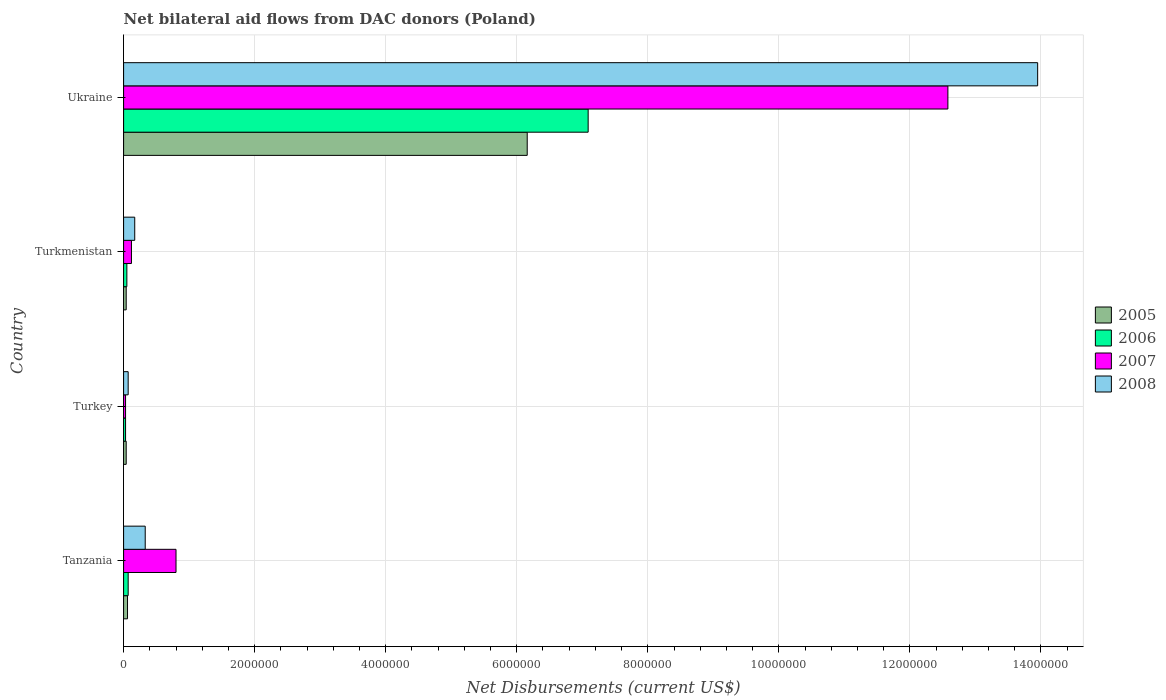How many different coloured bars are there?
Make the answer very short. 4. How many groups of bars are there?
Give a very brief answer. 4. Are the number of bars per tick equal to the number of legend labels?
Give a very brief answer. Yes. How many bars are there on the 2nd tick from the bottom?
Ensure brevity in your answer.  4. Across all countries, what is the maximum net bilateral aid flows in 2006?
Keep it short and to the point. 7.09e+06. In which country was the net bilateral aid flows in 2008 maximum?
Your answer should be very brief. Ukraine. In which country was the net bilateral aid flows in 2008 minimum?
Provide a succinct answer. Turkey. What is the total net bilateral aid flows in 2008 in the graph?
Give a very brief answer. 1.45e+07. What is the difference between the net bilateral aid flows in 2005 in Turkmenistan and that in Ukraine?
Provide a short and direct response. -6.12e+06. What is the difference between the net bilateral aid flows in 2006 in Ukraine and the net bilateral aid flows in 2005 in Turkmenistan?
Give a very brief answer. 7.05e+06. What is the average net bilateral aid flows in 2006 per country?
Your answer should be very brief. 1.81e+06. What is the difference between the net bilateral aid flows in 2006 and net bilateral aid flows in 2005 in Turkmenistan?
Your answer should be very brief. 10000. What is the ratio of the net bilateral aid flows in 2007 in Tanzania to that in Turkmenistan?
Provide a short and direct response. 6.67. Is the net bilateral aid flows in 2006 in Tanzania less than that in Ukraine?
Make the answer very short. Yes. What is the difference between the highest and the second highest net bilateral aid flows in 2007?
Provide a short and direct response. 1.18e+07. What is the difference between the highest and the lowest net bilateral aid flows in 2008?
Give a very brief answer. 1.39e+07. In how many countries, is the net bilateral aid flows in 2006 greater than the average net bilateral aid flows in 2006 taken over all countries?
Provide a succinct answer. 1. Is the sum of the net bilateral aid flows in 2006 in Tanzania and Turkmenistan greater than the maximum net bilateral aid flows in 2008 across all countries?
Make the answer very short. No. Is it the case that in every country, the sum of the net bilateral aid flows in 2008 and net bilateral aid flows in 2005 is greater than the sum of net bilateral aid flows in 2006 and net bilateral aid flows in 2007?
Keep it short and to the point. No. What does the 3rd bar from the top in Turkey represents?
Offer a terse response. 2006. What does the 1st bar from the bottom in Turkmenistan represents?
Offer a very short reply. 2005. How many bars are there?
Make the answer very short. 16. Does the graph contain grids?
Your answer should be compact. Yes. What is the title of the graph?
Ensure brevity in your answer.  Net bilateral aid flows from DAC donors (Poland). Does "1982" appear as one of the legend labels in the graph?
Make the answer very short. No. What is the label or title of the X-axis?
Provide a succinct answer. Net Disbursements (current US$). What is the label or title of the Y-axis?
Your answer should be compact. Country. What is the Net Disbursements (current US$) of 2005 in Tanzania?
Ensure brevity in your answer.  6.00e+04. What is the Net Disbursements (current US$) in 2006 in Tanzania?
Offer a very short reply. 7.00e+04. What is the Net Disbursements (current US$) in 2006 in Turkey?
Your answer should be very brief. 3.00e+04. What is the Net Disbursements (current US$) of 2007 in Turkmenistan?
Your answer should be very brief. 1.20e+05. What is the Net Disbursements (current US$) in 2005 in Ukraine?
Make the answer very short. 6.16e+06. What is the Net Disbursements (current US$) of 2006 in Ukraine?
Give a very brief answer. 7.09e+06. What is the Net Disbursements (current US$) of 2007 in Ukraine?
Your response must be concise. 1.26e+07. What is the Net Disbursements (current US$) of 2008 in Ukraine?
Offer a very short reply. 1.40e+07. Across all countries, what is the maximum Net Disbursements (current US$) of 2005?
Offer a very short reply. 6.16e+06. Across all countries, what is the maximum Net Disbursements (current US$) in 2006?
Give a very brief answer. 7.09e+06. Across all countries, what is the maximum Net Disbursements (current US$) in 2007?
Make the answer very short. 1.26e+07. Across all countries, what is the maximum Net Disbursements (current US$) of 2008?
Your answer should be very brief. 1.40e+07. Across all countries, what is the minimum Net Disbursements (current US$) in 2006?
Give a very brief answer. 3.00e+04. Across all countries, what is the minimum Net Disbursements (current US$) of 2007?
Keep it short and to the point. 3.00e+04. Across all countries, what is the minimum Net Disbursements (current US$) in 2008?
Provide a succinct answer. 7.00e+04. What is the total Net Disbursements (current US$) in 2005 in the graph?
Ensure brevity in your answer.  6.30e+06. What is the total Net Disbursements (current US$) of 2006 in the graph?
Your answer should be compact. 7.24e+06. What is the total Net Disbursements (current US$) of 2007 in the graph?
Offer a terse response. 1.35e+07. What is the total Net Disbursements (current US$) of 2008 in the graph?
Provide a succinct answer. 1.45e+07. What is the difference between the Net Disbursements (current US$) of 2005 in Tanzania and that in Turkey?
Give a very brief answer. 2.00e+04. What is the difference between the Net Disbursements (current US$) of 2006 in Tanzania and that in Turkey?
Your answer should be very brief. 4.00e+04. What is the difference between the Net Disbursements (current US$) in 2007 in Tanzania and that in Turkey?
Ensure brevity in your answer.  7.70e+05. What is the difference between the Net Disbursements (current US$) in 2008 in Tanzania and that in Turkey?
Make the answer very short. 2.60e+05. What is the difference between the Net Disbursements (current US$) of 2006 in Tanzania and that in Turkmenistan?
Keep it short and to the point. 2.00e+04. What is the difference between the Net Disbursements (current US$) in 2007 in Tanzania and that in Turkmenistan?
Your answer should be very brief. 6.80e+05. What is the difference between the Net Disbursements (current US$) of 2005 in Tanzania and that in Ukraine?
Provide a succinct answer. -6.10e+06. What is the difference between the Net Disbursements (current US$) in 2006 in Tanzania and that in Ukraine?
Your response must be concise. -7.02e+06. What is the difference between the Net Disbursements (current US$) in 2007 in Tanzania and that in Ukraine?
Your answer should be compact. -1.18e+07. What is the difference between the Net Disbursements (current US$) of 2008 in Tanzania and that in Ukraine?
Your answer should be compact. -1.36e+07. What is the difference between the Net Disbursements (current US$) of 2005 in Turkey and that in Turkmenistan?
Provide a short and direct response. 0. What is the difference between the Net Disbursements (current US$) of 2008 in Turkey and that in Turkmenistan?
Your answer should be very brief. -1.00e+05. What is the difference between the Net Disbursements (current US$) in 2005 in Turkey and that in Ukraine?
Provide a short and direct response. -6.12e+06. What is the difference between the Net Disbursements (current US$) of 2006 in Turkey and that in Ukraine?
Offer a terse response. -7.06e+06. What is the difference between the Net Disbursements (current US$) of 2007 in Turkey and that in Ukraine?
Make the answer very short. -1.26e+07. What is the difference between the Net Disbursements (current US$) in 2008 in Turkey and that in Ukraine?
Make the answer very short. -1.39e+07. What is the difference between the Net Disbursements (current US$) in 2005 in Turkmenistan and that in Ukraine?
Provide a succinct answer. -6.12e+06. What is the difference between the Net Disbursements (current US$) of 2006 in Turkmenistan and that in Ukraine?
Your response must be concise. -7.04e+06. What is the difference between the Net Disbursements (current US$) of 2007 in Turkmenistan and that in Ukraine?
Give a very brief answer. -1.25e+07. What is the difference between the Net Disbursements (current US$) of 2008 in Turkmenistan and that in Ukraine?
Offer a very short reply. -1.38e+07. What is the difference between the Net Disbursements (current US$) of 2006 in Tanzania and the Net Disbursements (current US$) of 2008 in Turkey?
Provide a short and direct response. 0. What is the difference between the Net Disbursements (current US$) of 2007 in Tanzania and the Net Disbursements (current US$) of 2008 in Turkey?
Ensure brevity in your answer.  7.30e+05. What is the difference between the Net Disbursements (current US$) in 2005 in Tanzania and the Net Disbursements (current US$) in 2006 in Turkmenistan?
Your answer should be compact. 10000. What is the difference between the Net Disbursements (current US$) in 2005 in Tanzania and the Net Disbursements (current US$) in 2008 in Turkmenistan?
Provide a short and direct response. -1.10e+05. What is the difference between the Net Disbursements (current US$) in 2006 in Tanzania and the Net Disbursements (current US$) in 2007 in Turkmenistan?
Give a very brief answer. -5.00e+04. What is the difference between the Net Disbursements (current US$) in 2006 in Tanzania and the Net Disbursements (current US$) in 2008 in Turkmenistan?
Offer a terse response. -1.00e+05. What is the difference between the Net Disbursements (current US$) in 2007 in Tanzania and the Net Disbursements (current US$) in 2008 in Turkmenistan?
Make the answer very short. 6.30e+05. What is the difference between the Net Disbursements (current US$) of 2005 in Tanzania and the Net Disbursements (current US$) of 2006 in Ukraine?
Keep it short and to the point. -7.03e+06. What is the difference between the Net Disbursements (current US$) of 2005 in Tanzania and the Net Disbursements (current US$) of 2007 in Ukraine?
Your answer should be very brief. -1.25e+07. What is the difference between the Net Disbursements (current US$) in 2005 in Tanzania and the Net Disbursements (current US$) in 2008 in Ukraine?
Provide a succinct answer. -1.39e+07. What is the difference between the Net Disbursements (current US$) in 2006 in Tanzania and the Net Disbursements (current US$) in 2007 in Ukraine?
Your answer should be compact. -1.25e+07. What is the difference between the Net Disbursements (current US$) in 2006 in Tanzania and the Net Disbursements (current US$) in 2008 in Ukraine?
Offer a very short reply. -1.39e+07. What is the difference between the Net Disbursements (current US$) in 2007 in Tanzania and the Net Disbursements (current US$) in 2008 in Ukraine?
Make the answer very short. -1.32e+07. What is the difference between the Net Disbursements (current US$) of 2005 in Turkey and the Net Disbursements (current US$) of 2006 in Turkmenistan?
Make the answer very short. -10000. What is the difference between the Net Disbursements (current US$) of 2005 in Turkey and the Net Disbursements (current US$) of 2008 in Turkmenistan?
Your answer should be very brief. -1.30e+05. What is the difference between the Net Disbursements (current US$) in 2006 in Turkey and the Net Disbursements (current US$) in 2007 in Turkmenistan?
Your answer should be very brief. -9.00e+04. What is the difference between the Net Disbursements (current US$) in 2007 in Turkey and the Net Disbursements (current US$) in 2008 in Turkmenistan?
Your answer should be compact. -1.40e+05. What is the difference between the Net Disbursements (current US$) in 2005 in Turkey and the Net Disbursements (current US$) in 2006 in Ukraine?
Offer a very short reply. -7.05e+06. What is the difference between the Net Disbursements (current US$) of 2005 in Turkey and the Net Disbursements (current US$) of 2007 in Ukraine?
Provide a succinct answer. -1.25e+07. What is the difference between the Net Disbursements (current US$) in 2005 in Turkey and the Net Disbursements (current US$) in 2008 in Ukraine?
Offer a very short reply. -1.39e+07. What is the difference between the Net Disbursements (current US$) in 2006 in Turkey and the Net Disbursements (current US$) in 2007 in Ukraine?
Give a very brief answer. -1.26e+07. What is the difference between the Net Disbursements (current US$) in 2006 in Turkey and the Net Disbursements (current US$) in 2008 in Ukraine?
Give a very brief answer. -1.39e+07. What is the difference between the Net Disbursements (current US$) in 2007 in Turkey and the Net Disbursements (current US$) in 2008 in Ukraine?
Your answer should be compact. -1.39e+07. What is the difference between the Net Disbursements (current US$) of 2005 in Turkmenistan and the Net Disbursements (current US$) of 2006 in Ukraine?
Keep it short and to the point. -7.05e+06. What is the difference between the Net Disbursements (current US$) of 2005 in Turkmenistan and the Net Disbursements (current US$) of 2007 in Ukraine?
Provide a succinct answer. -1.25e+07. What is the difference between the Net Disbursements (current US$) of 2005 in Turkmenistan and the Net Disbursements (current US$) of 2008 in Ukraine?
Provide a succinct answer. -1.39e+07. What is the difference between the Net Disbursements (current US$) in 2006 in Turkmenistan and the Net Disbursements (current US$) in 2007 in Ukraine?
Provide a short and direct response. -1.25e+07. What is the difference between the Net Disbursements (current US$) of 2006 in Turkmenistan and the Net Disbursements (current US$) of 2008 in Ukraine?
Your answer should be compact. -1.39e+07. What is the difference between the Net Disbursements (current US$) of 2007 in Turkmenistan and the Net Disbursements (current US$) of 2008 in Ukraine?
Give a very brief answer. -1.38e+07. What is the average Net Disbursements (current US$) in 2005 per country?
Give a very brief answer. 1.58e+06. What is the average Net Disbursements (current US$) in 2006 per country?
Offer a very short reply. 1.81e+06. What is the average Net Disbursements (current US$) of 2007 per country?
Offer a very short reply. 3.38e+06. What is the average Net Disbursements (current US$) in 2008 per country?
Provide a succinct answer. 3.63e+06. What is the difference between the Net Disbursements (current US$) of 2005 and Net Disbursements (current US$) of 2007 in Tanzania?
Give a very brief answer. -7.40e+05. What is the difference between the Net Disbursements (current US$) of 2006 and Net Disbursements (current US$) of 2007 in Tanzania?
Keep it short and to the point. -7.30e+05. What is the difference between the Net Disbursements (current US$) in 2007 and Net Disbursements (current US$) in 2008 in Tanzania?
Provide a succinct answer. 4.70e+05. What is the difference between the Net Disbursements (current US$) in 2005 and Net Disbursements (current US$) in 2007 in Turkey?
Keep it short and to the point. 10000. What is the difference between the Net Disbursements (current US$) in 2006 and Net Disbursements (current US$) in 2007 in Turkey?
Offer a terse response. 0. What is the difference between the Net Disbursements (current US$) of 2005 and Net Disbursements (current US$) of 2006 in Turkmenistan?
Your answer should be compact. -10000. What is the difference between the Net Disbursements (current US$) in 2006 and Net Disbursements (current US$) in 2007 in Turkmenistan?
Keep it short and to the point. -7.00e+04. What is the difference between the Net Disbursements (current US$) in 2006 and Net Disbursements (current US$) in 2008 in Turkmenistan?
Give a very brief answer. -1.20e+05. What is the difference between the Net Disbursements (current US$) in 2005 and Net Disbursements (current US$) in 2006 in Ukraine?
Provide a succinct answer. -9.30e+05. What is the difference between the Net Disbursements (current US$) of 2005 and Net Disbursements (current US$) of 2007 in Ukraine?
Make the answer very short. -6.42e+06. What is the difference between the Net Disbursements (current US$) of 2005 and Net Disbursements (current US$) of 2008 in Ukraine?
Your answer should be very brief. -7.79e+06. What is the difference between the Net Disbursements (current US$) in 2006 and Net Disbursements (current US$) in 2007 in Ukraine?
Offer a terse response. -5.49e+06. What is the difference between the Net Disbursements (current US$) of 2006 and Net Disbursements (current US$) of 2008 in Ukraine?
Your response must be concise. -6.86e+06. What is the difference between the Net Disbursements (current US$) in 2007 and Net Disbursements (current US$) in 2008 in Ukraine?
Your answer should be very brief. -1.37e+06. What is the ratio of the Net Disbursements (current US$) of 2006 in Tanzania to that in Turkey?
Make the answer very short. 2.33. What is the ratio of the Net Disbursements (current US$) in 2007 in Tanzania to that in Turkey?
Keep it short and to the point. 26.67. What is the ratio of the Net Disbursements (current US$) of 2008 in Tanzania to that in Turkey?
Offer a very short reply. 4.71. What is the ratio of the Net Disbursements (current US$) in 2006 in Tanzania to that in Turkmenistan?
Keep it short and to the point. 1.4. What is the ratio of the Net Disbursements (current US$) of 2007 in Tanzania to that in Turkmenistan?
Your response must be concise. 6.67. What is the ratio of the Net Disbursements (current US$) of 2008 in Tanzania to that in Turkmenistan?
Offer a very short reply. 1.94. What is the ratio of the Net Disbursements (current US$) of 2005 in Tanzania to that in Ukraine?
Your answer should be very brief. 0.01. What is the ratio of the Net Disbursements (current US$) in 2006 in Tanzania to that in Ukraine?
Ensure brevity in your answer.  0.01. What is the ratio of the Net Disbursements (current US$) of 2007 in Tanzania to that in Ukraine?
Make the answer very short. 0.06. What is the ratio of the Net Disbursements (current US$) in 2008 in Tanzania to that in Ukraine?
Provide a succinct answer. 0.02. What is the ratio of the Net Disbursements (current US$) of 2005 in Turkey to that in Turkmenistan?
Make the answer very short. 1. What is the ratio of the Net Disbursements (current US$) of 2006 in Turkey to that in Turkmenistan?
Make the answer very short. 0.6. What is the ratio of the Net Disbursements (current US$) of 2008 in Turkey to that in Turkmenistan?
Keep it short and to the point. 0.41. What is the ratio of the Net Disbursements (current US$) of 2005 in Turkey to that in Ukraine?
Make the answer very short. 0.01. What is the ratio of the Net Disbursements (current US$) of 2006 in Turkey to that in Ukraine?
Your response must be concise. 0. What is the ratio of the Net Disbursements (current US$) of 2007 in Turkey to that in Ukraine?
Your answer should be very brief. 0. What is the ratio of the Net Disbursements (current US$) in 2008 in Turkey to that in Ukraine?
Your answer should be compact. 0.01. What is the ratio of the Net Disbursements (current US$) in 2005 in Turkmenistan to that in Ukraine?
Your answer should be very brief. 0.01. What is the ratio of the Net Disbursements (current US$) in 2006 in Turkmenistan to that in Ukraine?
Give a very brief answer. 0.01. What is the ratio of the Net Disbursements (current US$) of 2007 in Turkmenistan to that in Ukraine?
Offer a very short reply. 0.01. What is the ratio of the Net Disbursements (current US$) of 2008 in Turkmenistan to that in Ukraine?
Your answer should be very brief. 0.01. What is the difference between the highest and the second highest Net Disbursements (current US$) in 2005?
Provide a short and direct response. 6.10e+06. What is the difference between the highest and the second highest Net Disbursements (current US$) of 2006?
Keep it short and to the point. 7.02e+06. What is the difference between the highest and the second highest Net Disbursements (current US$) of 2007?
Your response must be concise. 1.18e+07. What is the difference between the highest and the second highest Net Disbursements (current US$) of 2008?
Your response must be concise. 1.36e+07. What is the difference between the highest and the lowest Net Disbursements (current US$) of 2005?
Ensure brevity in your answer.  6.12e+06. What is the difference between the highest and the lowest Net Disbursements (current US$) of 2006?
Offer a terse response. 7.06e+06. What is the difference between the highest and the lowest Net Disbursements (current US$) of 2007?
Ensure brevity in your answer.  1.26e+07. What is the difference between the highest and the lowest Net Disbursements (current US$) in 2008?
Give a very brief answer. 1.39e+07. 